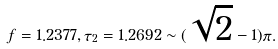Convert formula to latex. <formula><loc_0><loc_0><loc_500><loc_500>f = 1 . 2 3 7 7 , \tau _ { 2 } = 1 . 2 6 9 2 \sim ( \sqrt { 2 } - 1 ) \pi .</formula> 